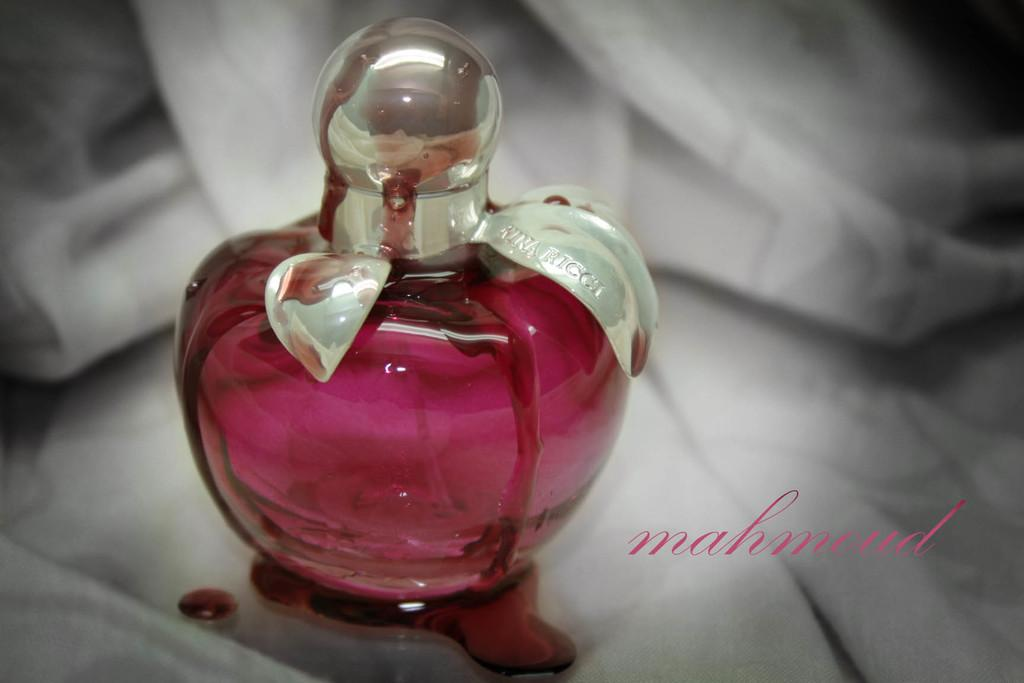<image>
Create a compact narrative representing the image presented. A bottle of Mahmoud perfume that is sitting on a table. 